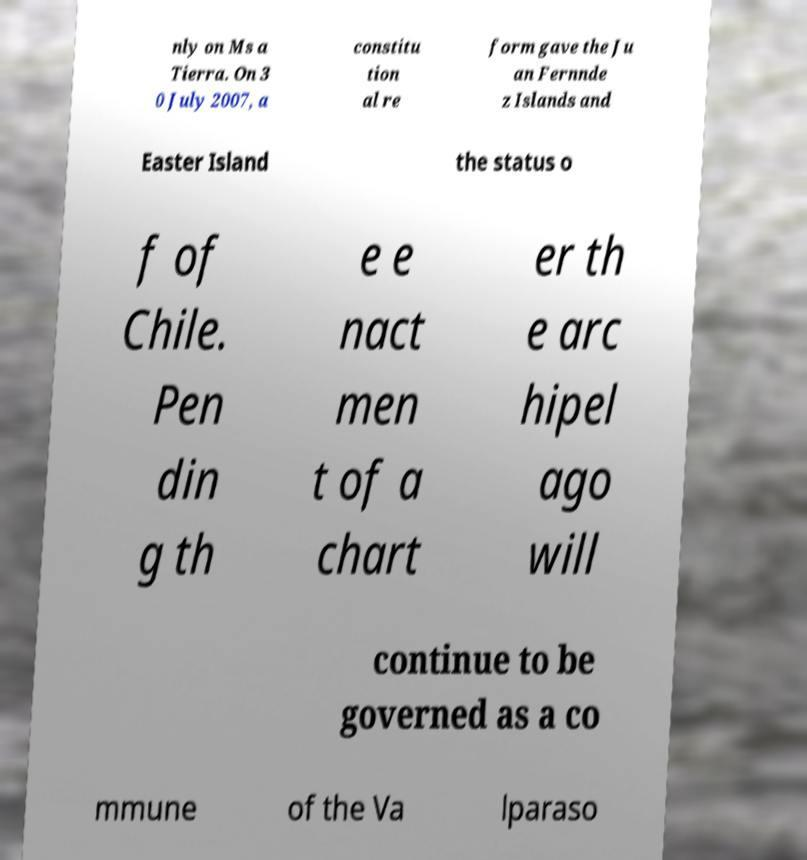Can you read and provide the text displayed in the image?This photo seems to have some interesting text. Can you extract and type it out for me? nly on Ms a Tierra. On 3 0 July 2007, a constitu tion al re form gave the Ju an Fernnde z Islands and Easter Island the status o f of Chile. Pen din g th e e nact men t of a chart er th e arc hipel ago will continue to be governed as a co mmune of the Va lparaso 